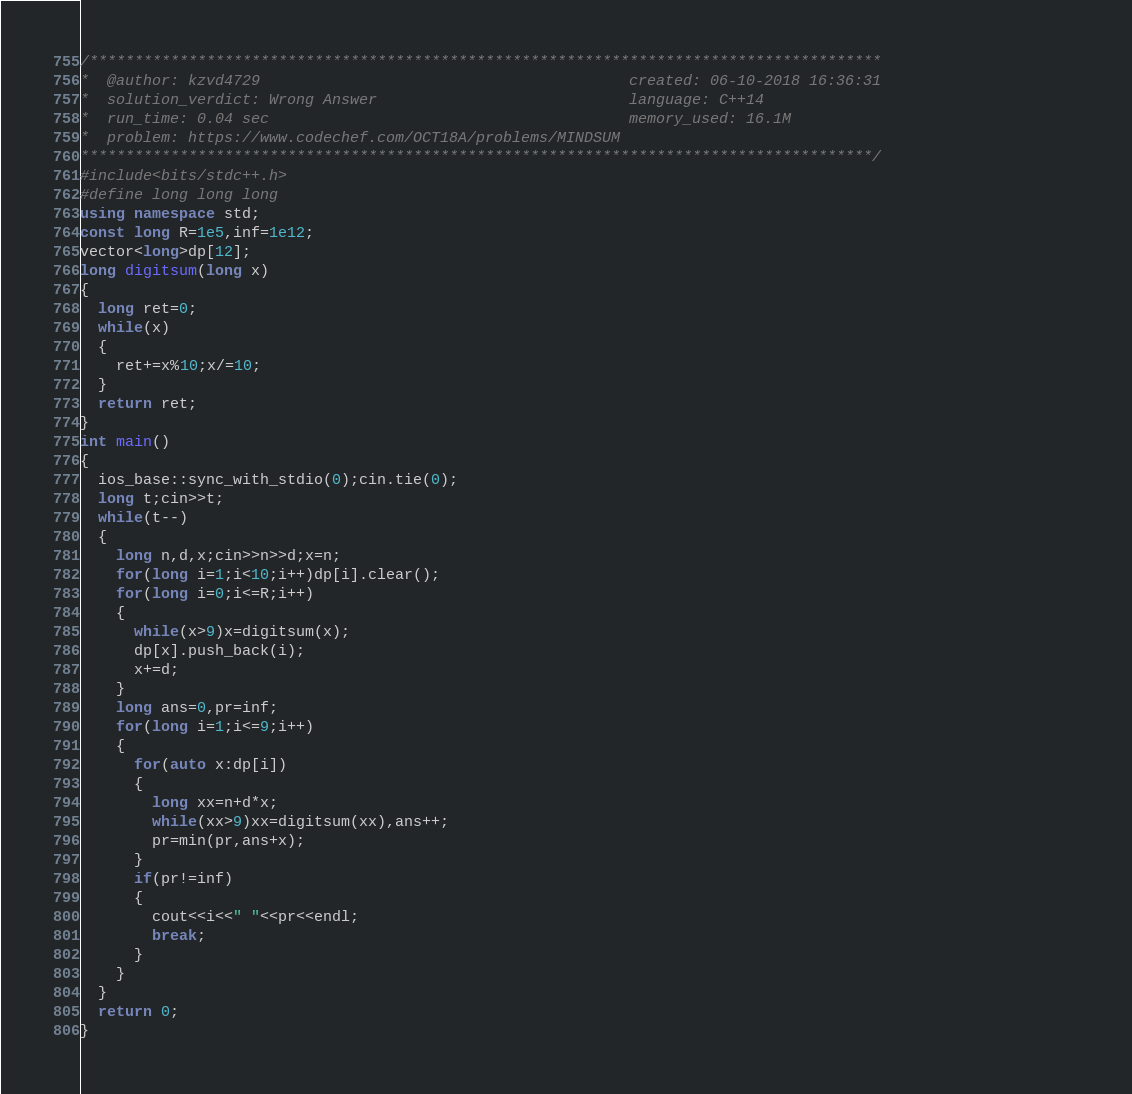Convert code to text. <code><loc_0><loc_0><loc_500><loc_500><_C++_>/****************************************************************************************
*  @author: kzvd4729                                         created: 06-10-2018 16:36:31                      
*  solution_verdict: Wrong Answer                            language: C++14                                   
*  run_time: 0.04 sec                                        memory_used: 16.1M                                
*  problem: https://www.codechef.com/OCT18A/problems/MINDSUM
****************************************************************************************/
#include<bits/stdc++.h>
#define long long long
using namespace std;
const long R=1e5,inf=1e12;
vector<long>dp[12];
long digitsum(long x)
{
  long ret=0;
  while(x)
  {
    ret+=x%10;x/=10;
  }
  return ret;
}
int main()
{
  ios_base::sync_with_stdio(0);cin.tie(0);
  long t;cin>>t;
  while(t--)
  {
    long n,d,x;cin>>n>>d;x=n;
    for(long i=1;i<10;i++)dp[i].clear();
    for(long i=0;i<=R;i++)
    {
      while(x>9)x=digitsum(x);
      dp[x].push_back(i);
      x+=d;
    }
    long ans=0,pr=inf;
    for(long i=1;i<=9;i++)
    {
      for(auto x:dp[i])
      {
        long xx=n+d*x;
        while(xx>9)xx=digitsum(xx),ans++;
        pr=min(pr,ans+x);
      }
      if(pr!=inf)
      {
        cout<<i<<" "<<pr<<endl;
        break;
      }
    }
  }
  return 0;
}</code> 